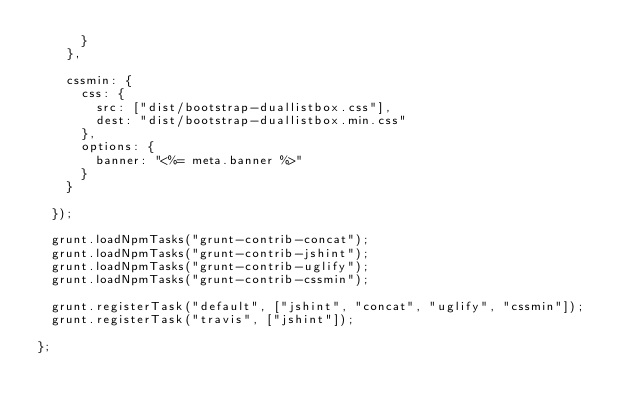<code> <loc_0><loc_0><loc_500><loc_500><_JavaScript_>      }
    },

    cssmin: {
      css: {
        src: ["dist/bootstrap-duallistbox.css"],
        dest: "dist/bootstrap-duallistbox.min.css"
      },
      options: {
        banner: "<%= meta.banner %>"
      }
    }

  });

  grunt.loadNpmTasks("grunt-contrib-concat");
  grunt.loadNpmTasks("grunt-contrib-jshint");
  grunt.loadNpmTasks("grunt-contrib-uglify");
  grunt.loadNpmTasks("grunt-contrib-cssmin");

  grunt.registerTask("default", ["jshint", "concat", "uglify", "cssmin"]);
  grunt.registerTask("travis", ["jshint"]);

};
</code> 